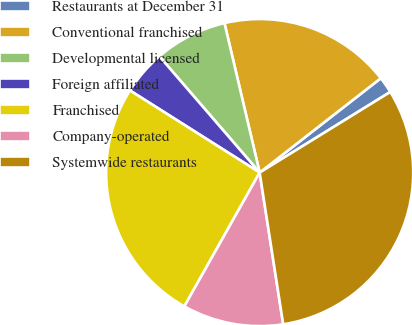Convert chart to OTSL. <chart><loc_0><loc_0><loc_500><loc_500><pie_chart><fcel>Restaurants at December 31<fcel>Conventional franchised<fcel>Developmental licensed<fcel>Foreign affiliated<fcel>Franchised<fcel>Company-operated<fcel>Systemwide restaurants<nl><fcel>1.73%<fcel>18.15%<fcel>7.65%<fcel>4.69%<fcel>25.82%<fcel>10.61%<fcel>31.35%<nl></chart> 